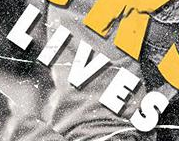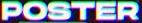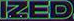What words are shown in these images in order, separated by a semicolon? LIVES; POSTER; IZED 